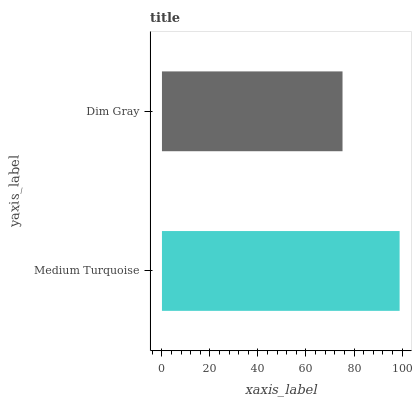Is Dim Gray the minimum?
Answer yes or no. Yes. Is Medium Turquoise the maximum?
Answer yes or no. Yes. Is Dim Gray the maximum?
Answer yes or no. No. Is Medium Turquoise greater than Dim Gray?
Answer yes or no. Yes. Is Dim Gray less than Medium Turquoise?
Answer yes or no. Yes. Is Dim Gray greater than Medium Turquoise?
Answer yes or no. No. Is Medium Turquoise less than Dim Gray?
Answer yes or no. No. Is Medium Turquoise the high median?
Answer yes or no. Yes. Is Dim Gray the low median?
Answer yes or no. Yes. Is Dim Gray the high median?
Answer yes or no. No. Is Medium Turquoise the low median?
Answer yes or no. No. 